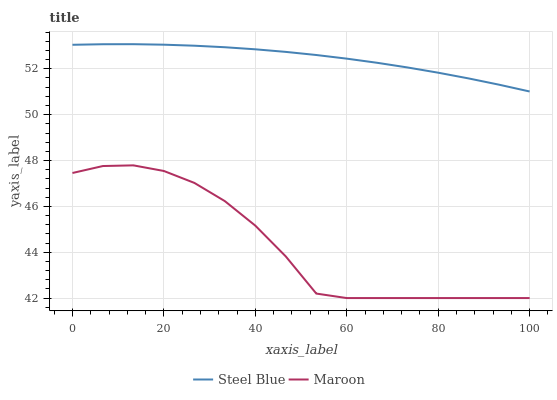Does Maroon have the minimum area under the curve?
Answer yes or no. Yes. Does Steel Blue have the maximum area under the curve?
Answer yes or no. Yes. Does Maroon have the maximum area under the curve?
Answer yes or no. No. Is Steel Blue the smoothest?
Answer yes or no. Yes. Is Maroon the roughest?
Answer yes or no. Yes. Is Maroon the smoothest?
Answer yes or no. No. Does Maroon have the lowest value?
Answer yes or no. Yes. Does Steel Blue have the highest value?
Answer yes or no. Yes. Does Maroon have the highest value?
Answer yes or no. No. Is Maroon less than Steel Blue?
Answer yes or no. Yes. Is Steel Blue greater than Maroon?
Answer yes or no. Yes. Does Maroon intersect Steel Blue?
Answer yes or no. No. 